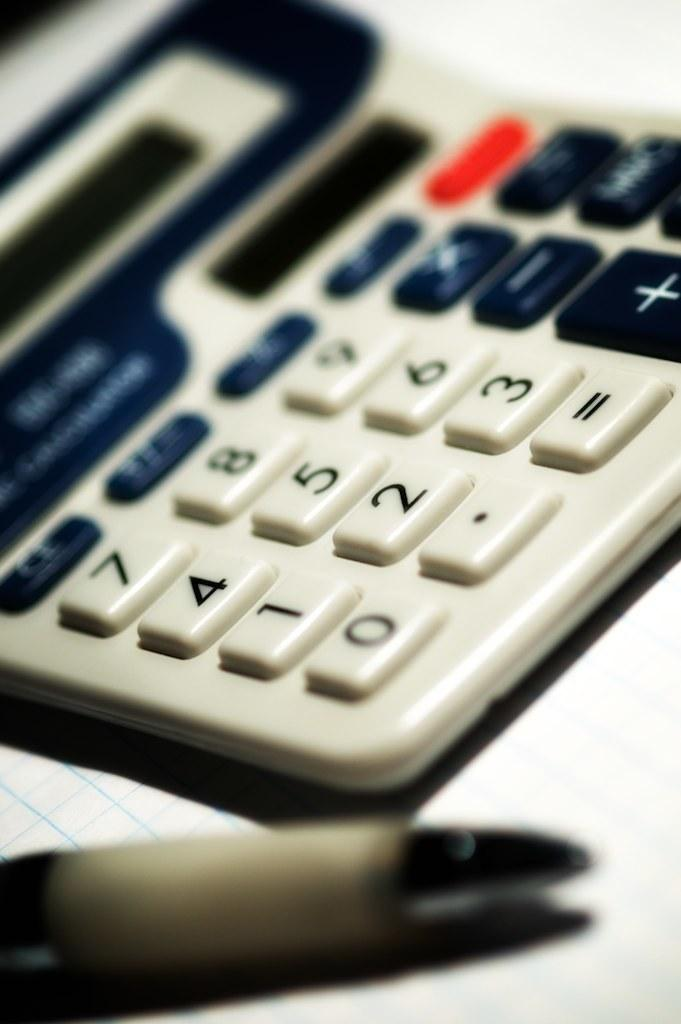<image>
Write a terse but informative summary of the picture. A calculator includes keys for 7, 8, and 9. 